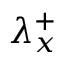Convert formula to latex. <formula><loc_0><loc_0><loc_500><loc_500>{ { \lambda } _ { x } ^ { + } }</formula> 